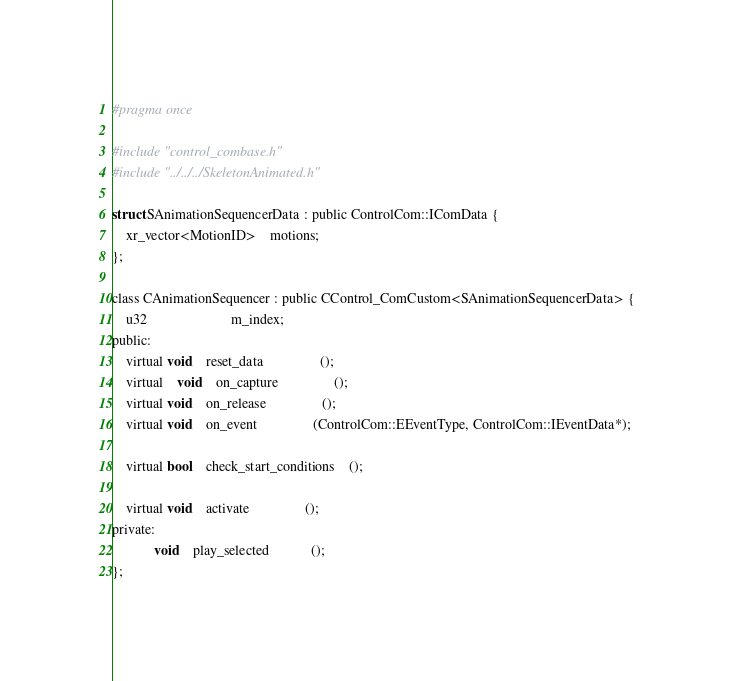<code> <loc_0><loc_0><loc_500><loc_500><_C_>#pragma once

#include "control_combase.h"
#include "../../../SkeletonAnimated.h"

struct SAnimationSequencerData : public ControlCom::IComData {
	xr_vector<MotionID>	motions;
};
	
class CAnimationSequencer : public CControl_ComCustom<SAnimationSequencerData> {
	u32						m_index;
public:
	virtual void	reset_data				();
	virtual	void	on_capture				();
	virtual void	on_release				();
	virtual void	on_event				(ControlCom::EEventType, ControlCom::IEventData*);

	virtual bool	check_start_conditions	();

	virtual void	activate				();
private:
			void	play_selected			();
};

</code> 